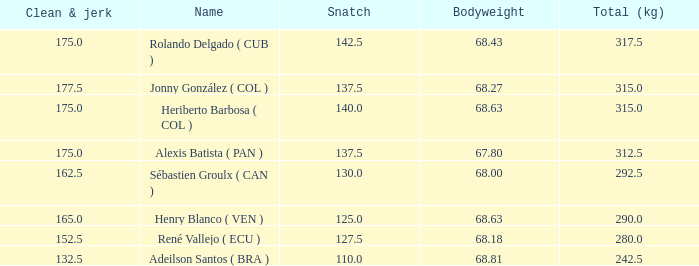Name the average clean and jerk for snatch of 140 and total kg less than 315 None. 